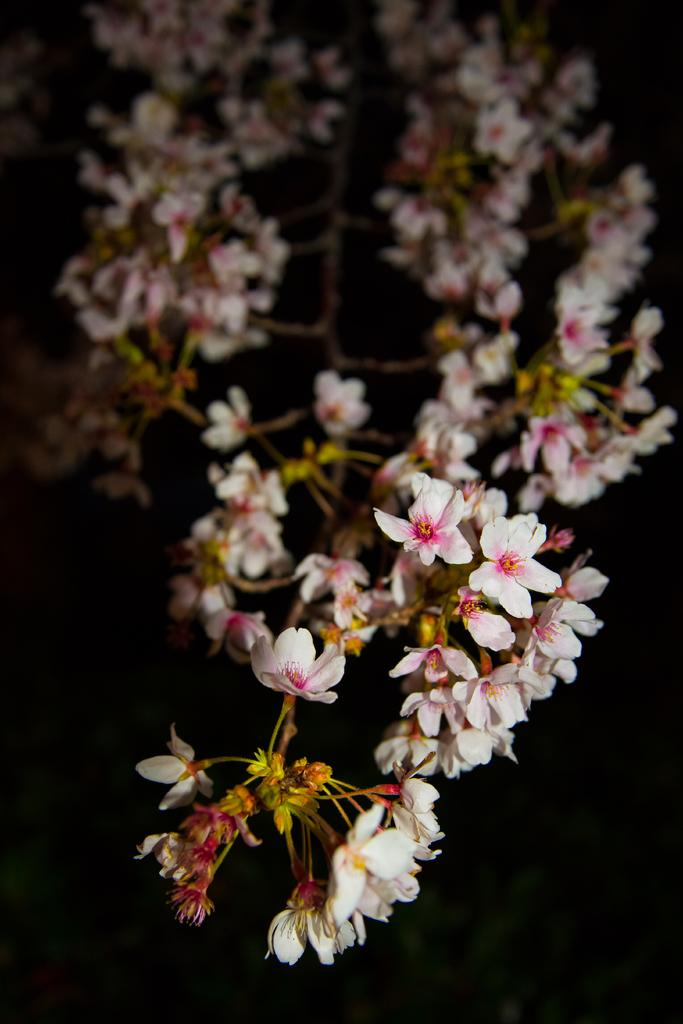What is the main subject of the image? The main subject of the image is a stem. What can be found on the stem? The stem has flowers and buds. Where is the monkey sitting on the stem in the image? There is no monkey present in the image; it only features a stem with flowers and buds. What type of sign can be seen hanging from the stem in the image? There is no sign present in the image; it only features a stem with flowers and buds. 